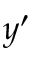Convert formula to latex. <formula><loc_0><loc_0><loc_500><loc_500>y ^ { \prime }</formula> 